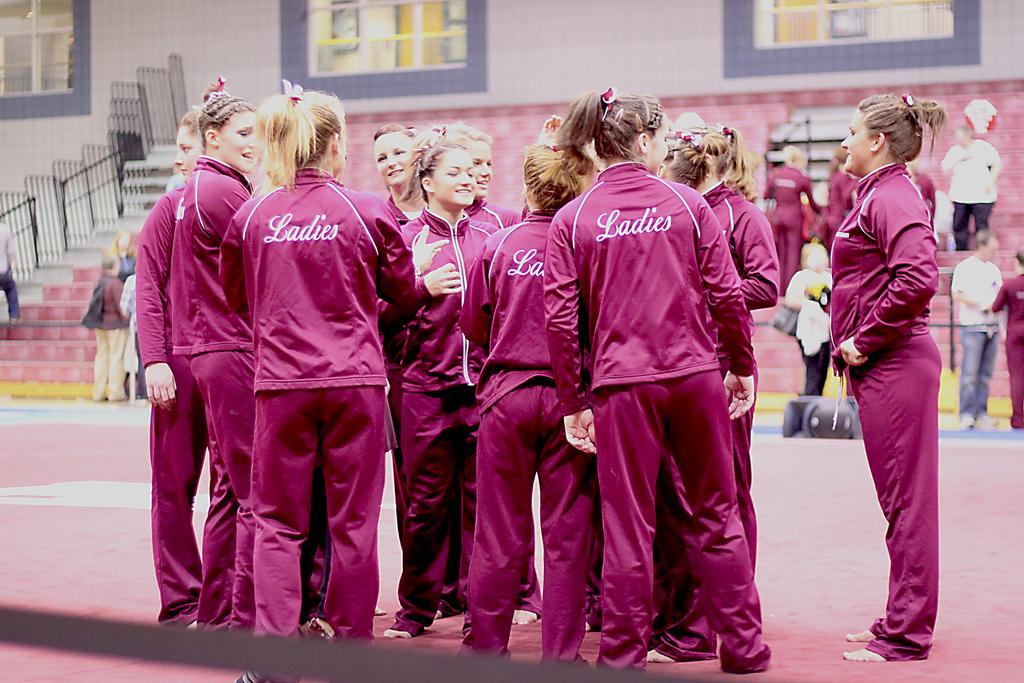<image>
Present a compact description of the photo's key features. players huddled toether wearing pink warm ups with ladies on back 